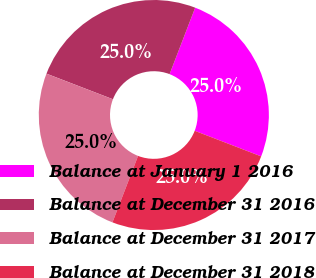Convert chart. <chart><loc_0><loc_0><loc_500><loc_500><pie_chart><fcel>Balance at January 1 2016<fcel>Balance at December 31 2016<fcel>Balance at December 31 2017<fcel>Balance at December 31 2018<nl><fcel>25.0%<fcel>25.0%<fcel>25.0%<fcel>25.0%<nl></chart> 